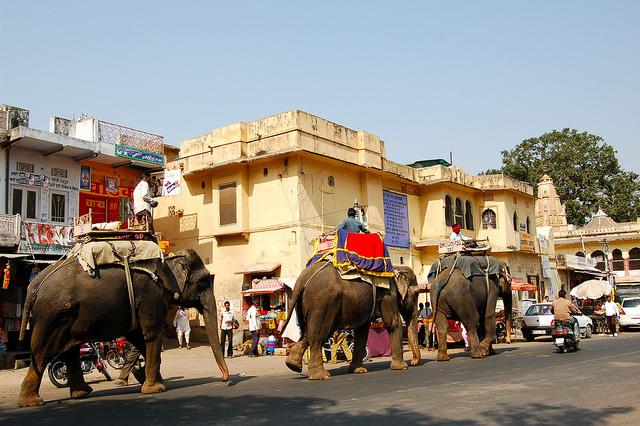Which mode of transport in use here uses less gasoline? elephants 